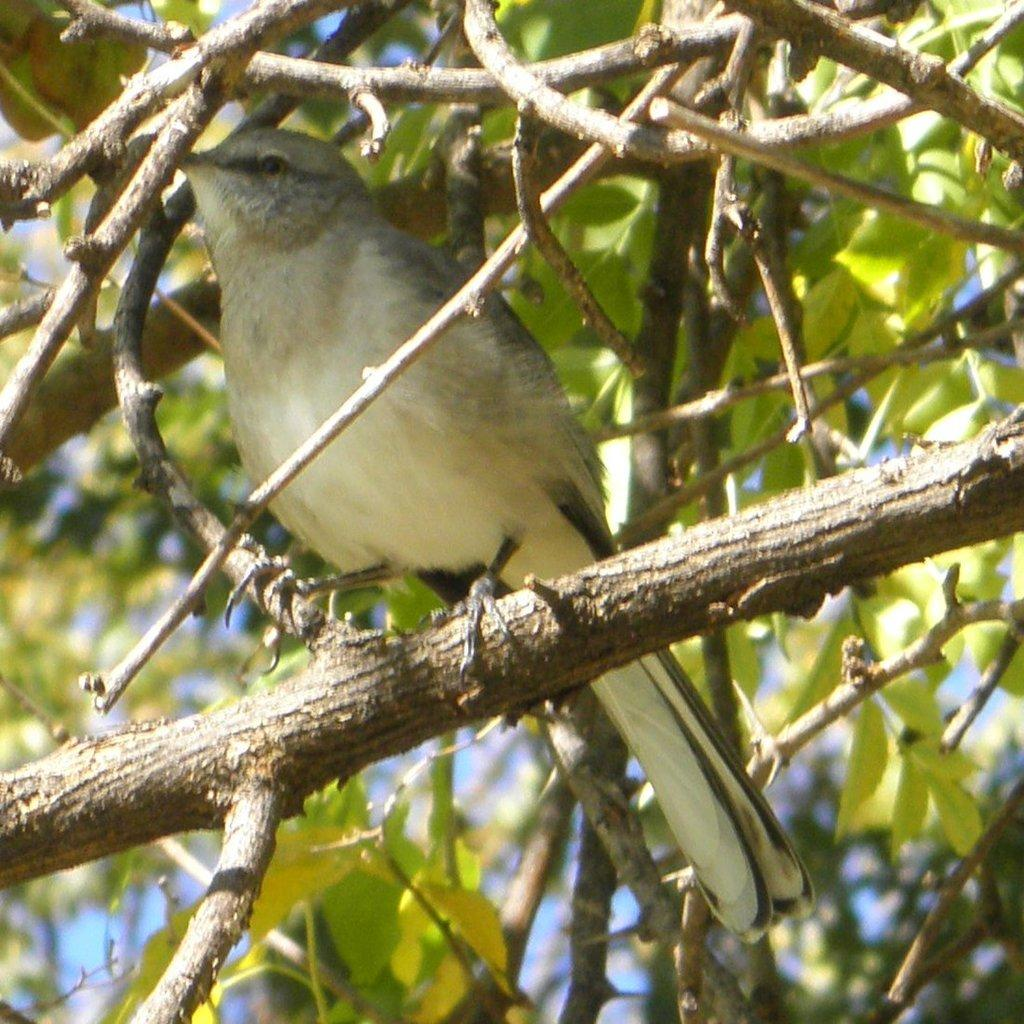What type of animal can be seen in the image? There is a bird in the image. What colors are present on the bird? The bird is cream, black, and brown in color. Where is the bird located in the image? The bird is on a tree branch. What can be seen in the background of the image? There are trees and the sky visible in the background of the image. What type of insurance policy does the bird have in the image? There is no mention of insurance in the image, as it features a bird on a tree branch with trees and the sky in the background. 